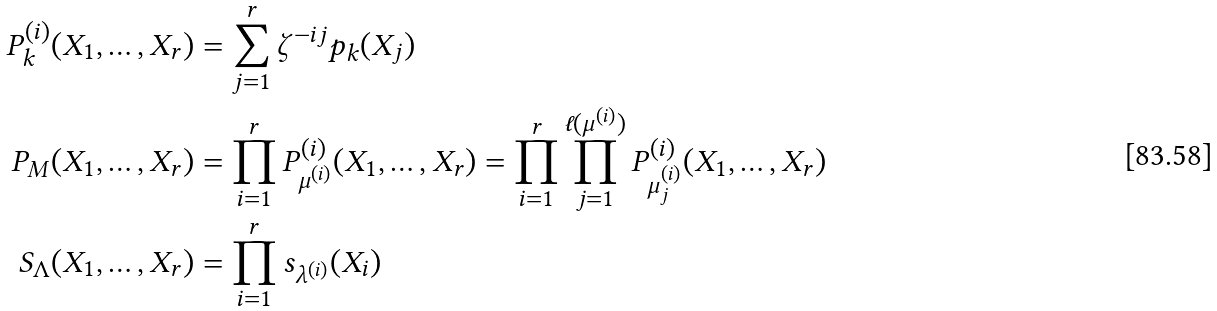Convert formula to latex. <formula><loc_0><loc_0><loc_500><loc_500>P _ { k } ^ { ( i ) } ( X _ { 1 } , \dots , X _ { r } ) & = \sum _ { j = 1 } ^ { r } \zeta ^ { - i j } p _ { k } ( X _ { j } ) \\ P _ { M } ( X _ { 1 } , \dots , X _ { r } ) & = \prod _ { i = 1 } ^ { r } P _ { \mu ^ { ( i ) } } ^ { ( i ) } ( X _ { 1 } , \dots , X _ { r } ) = \prod _ { i = 1 } ^ { r } \prod _ { j = 1 } ^ { \ell ( \mu ^ { ( i ) } ) } P _ { \mu ^ { ( i ) } _ { j } } ^ { ( i ) } ( X _ { 1 } , \dots , X _ { r } ) \\ S _ { \Lambda } ( X _ { 1 } , \dots , X _ { r } ) & = \prod _ { i = 1 } ^ { r } s _ { \lambda ^ { ( i ) } } ( X _ { i } )</formula> 